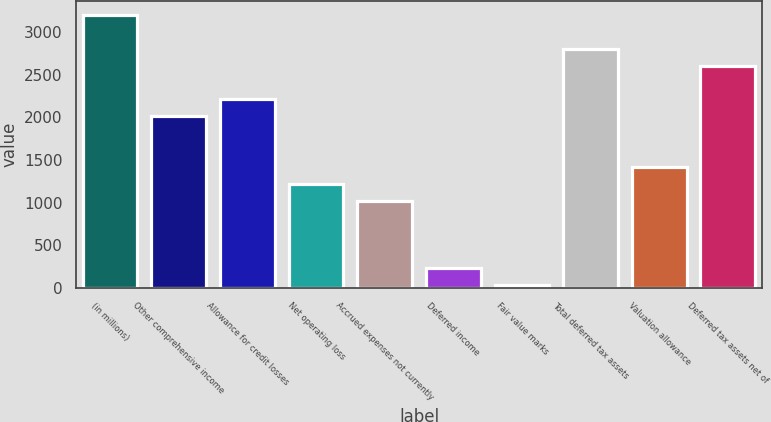<chart> <loc_0><loc_0><loc_500><loc_500><bar_chart><fcel>(in millions)<fcel>Other comprehensive income<fcel>Allowance for credit losses<fcel>Net operating loss<fcel>Accrued expenses not currently<fcel>Deferred income<fcel>Fair value marks<fcel>Total deferred tax assets<fcel>Valuation allowance<fcel>Deferred tax assets net of<nl><fcel>3202.8<fcel>2013<fcel>2211.3<fcel>1219.8<fcel>1021.5<fcel>228.3<fcel>30<fcel>2806.2<fcel>1418.1<fcel>2607.9<nl></chart> 